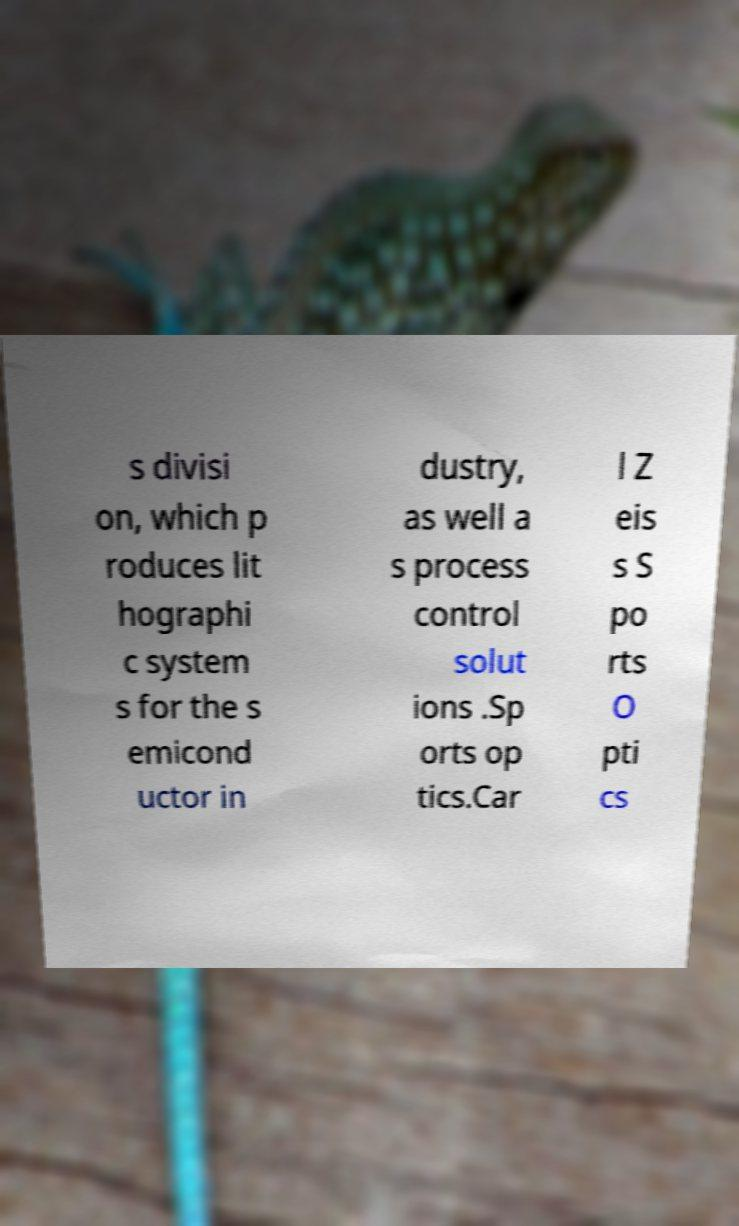Can you read and provide the text displayed in the image?This photo seems to have some interesting text. Can you extract and type it out for me? s divisi on, which p roduces lit hographi c system s for the s emicond uctor in dustry, as well a s process control solut ions .Sp orts op tics.Car l Z eis s S po rts O pti cs 